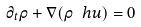<formula> <loc_0><loc_0><loc_500><loc_500>\partial _ { t } \rho + \nabla ( \rho \ h { u } ) = 0</formula> 